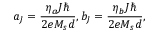<formula> <loc_0><loc_0><loc_500><loc_500>a _ { J } = \frac { \eta _ { a } J } { 2 e M _ { s } d } , b _ { J } = \frac { \eta _ { b } J } { 2 e M _ { s } d } ,</formula> 